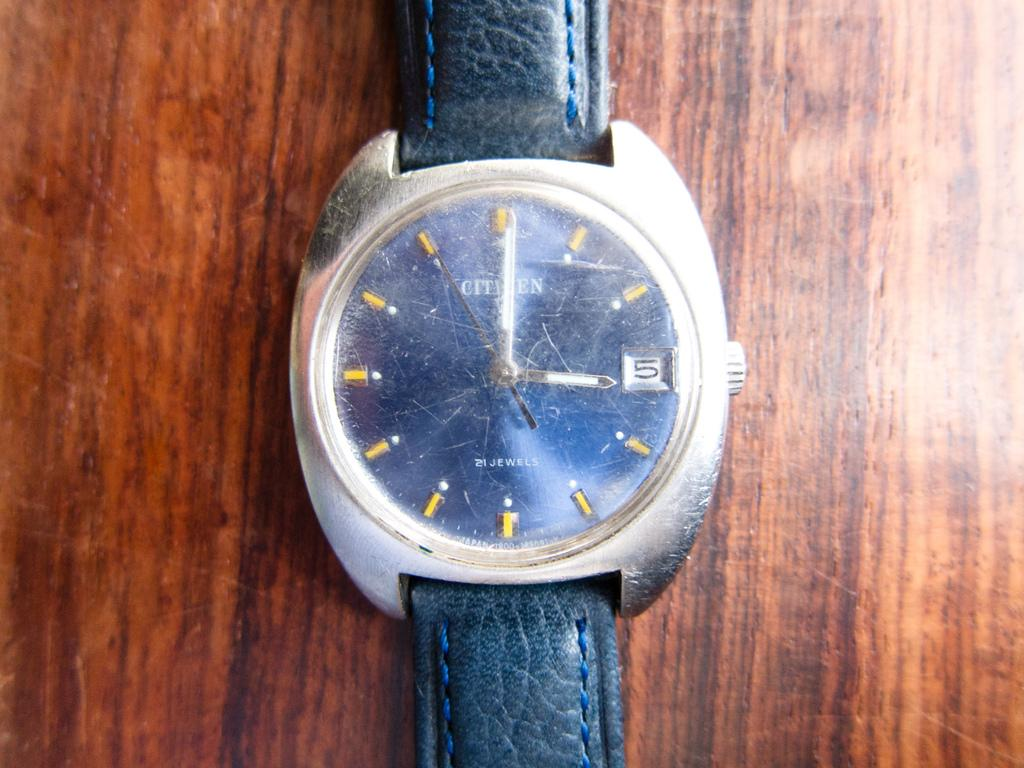<image>
Provide a brief description of the given image. A black and silver watch says "21 JEWELS" on the face. 